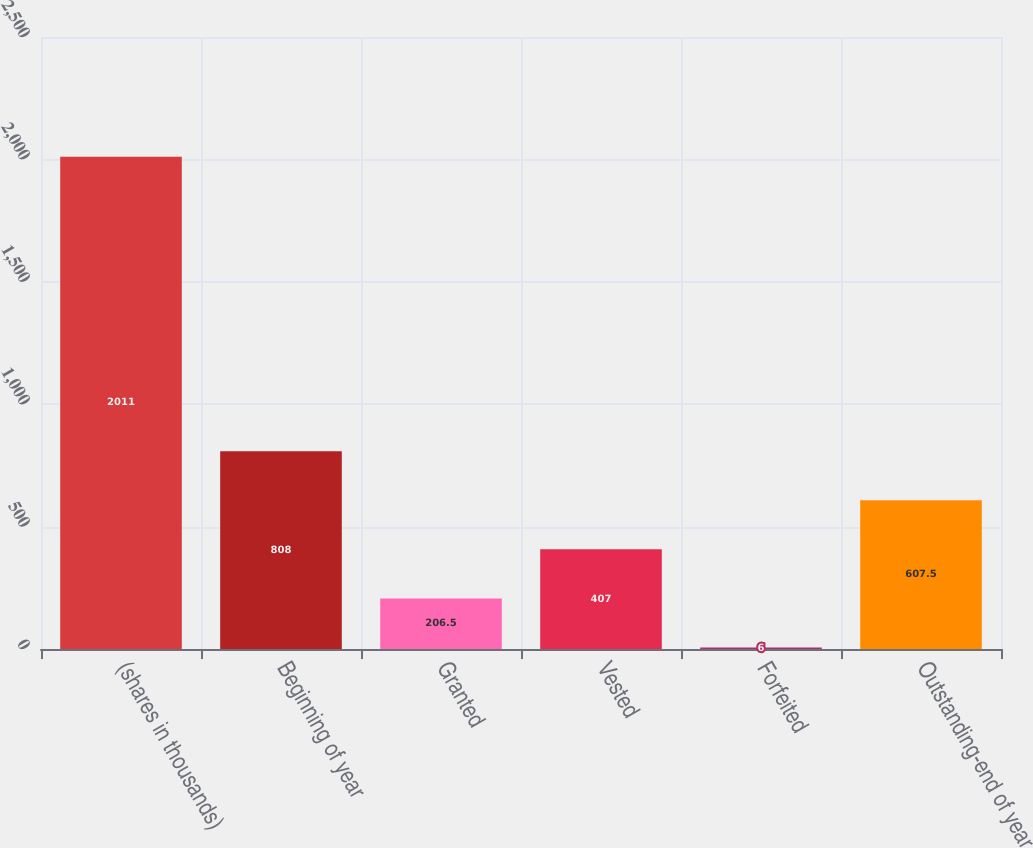Convert chart. <chart><loc_0><loc_0><loc_500><loc_500><bar_chart><fcel>(shares in thousands)<fcel>Beginning of year<fcel>Granted<fcel>Vested<fcel>Forfeited<fcel>Outstanding-end of year<nl><fcel>2011<fcel>808<fcel>206.5<fcel>407<fcel>6<fcel>607.5<nl></chart> 